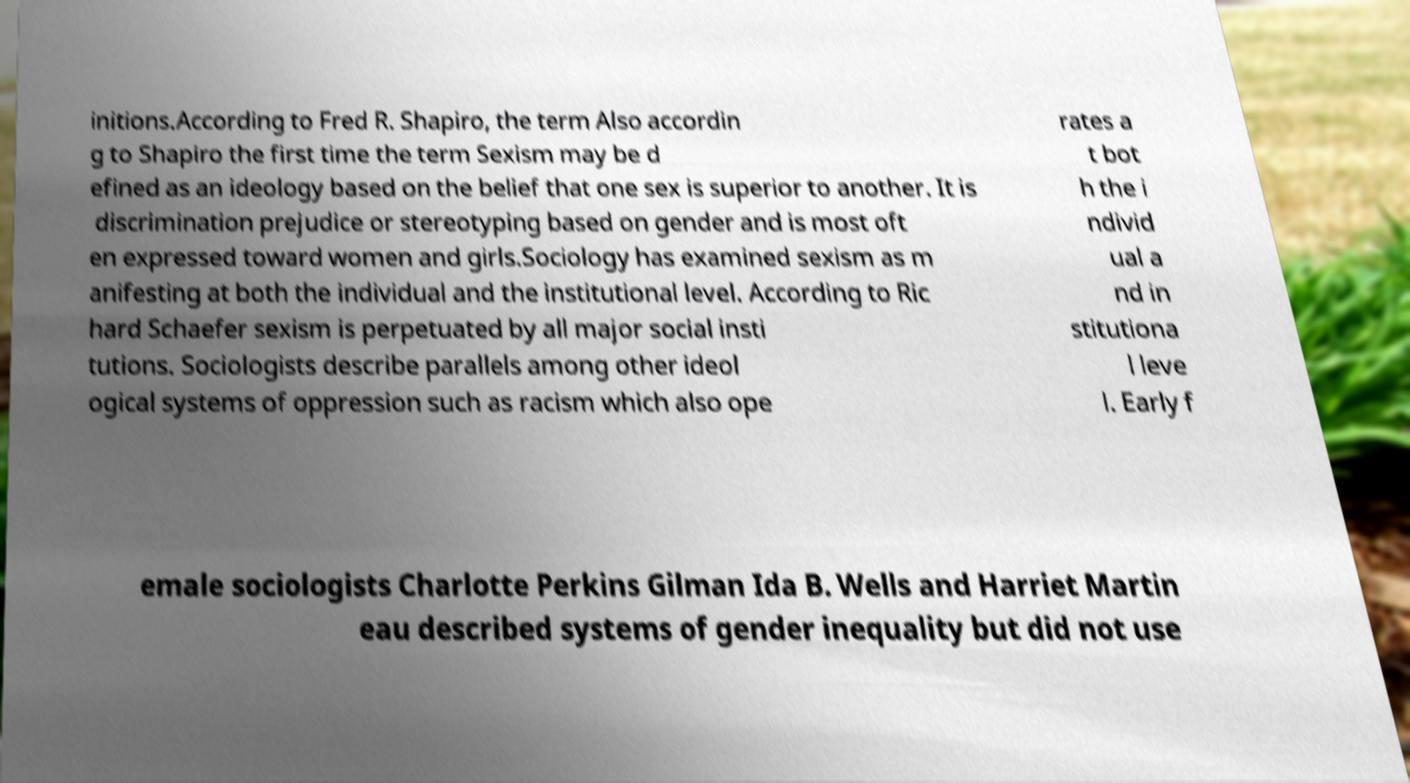For documentation purposes, I need the text within this image transcribed. Could you provide that? initions.According to Fred R. Shapiro, the term Also accordin g to Shapiro the first time the term Sexism may be d efined as an ideology based on the belief that one sex is superior to another. It is discrimination prejudice or stereotyping based on gender and is most oft en expressed toward women and girls.Sociology has examined sexism as m anifesting at both the individual and the institutional level. According to Ric hard Schaefer sexism is perpetuated by all major social insti tutions. Sociologists describe parallels among other ideol ogical systems of oppression such as racism which also ope rates a t bot h the i ndivid ual a nd in stitutiona l leve l. Early f emale sociologists Charlotte Perkins Gilman Ida B. Wells and Harriet Martin eau described systems of gender inequality but did not use 